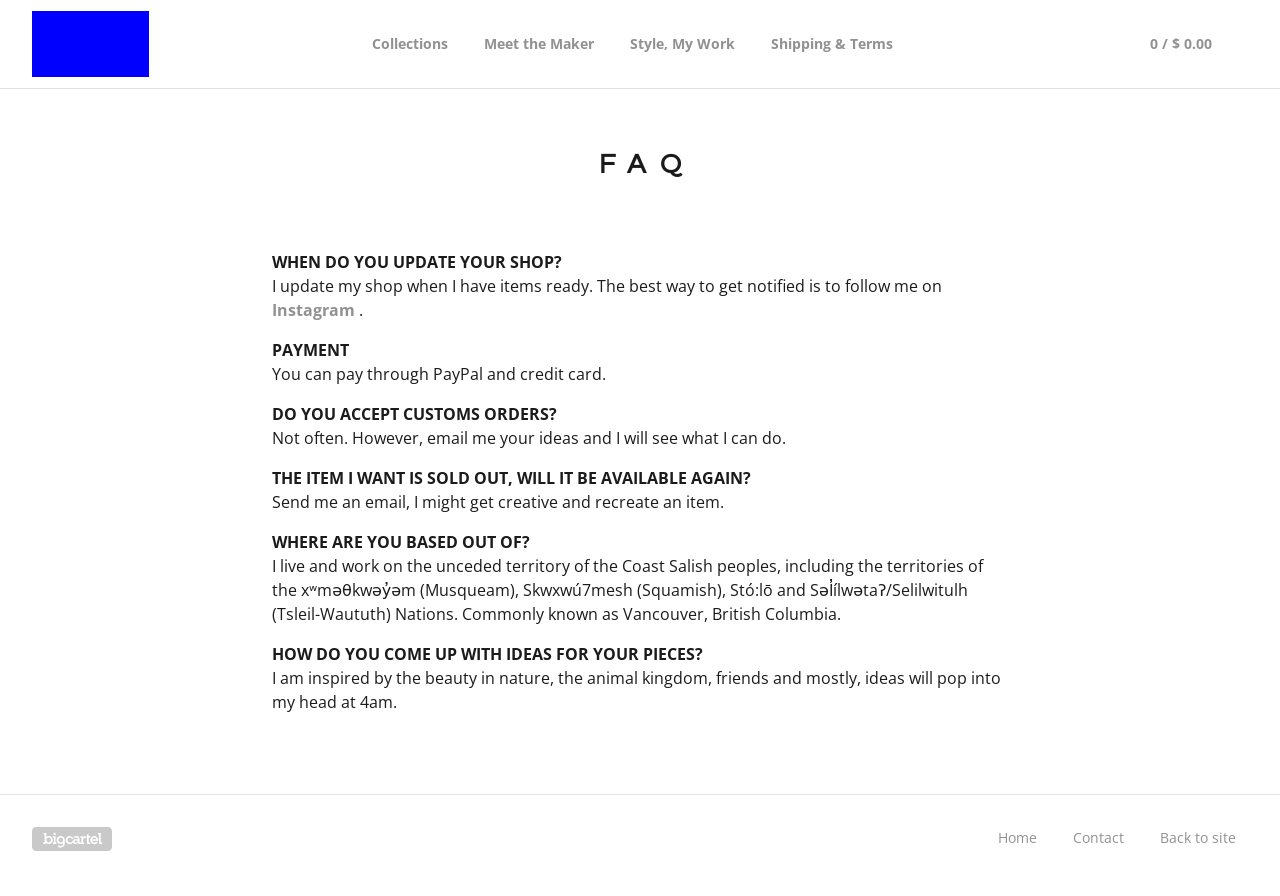Can you explain what topics are covered in the FAQ section shown in the image? The FAQ section in the image addresses various topics including shop updates, payment options, custom orders, availability of sold-out items, location details, and sources of inspiration for the products. 